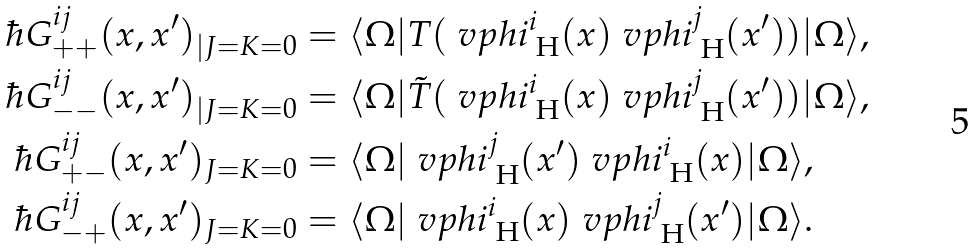Convert formula to latex. <formula><loc_0><loc_0><loc_500><loc_500>\hbar { G } ^ { i j } _ { + + } ( x , x ^ { \prime } ) _ { | J = K = 0 } & = \langle \Omega | T ( \ v p h i _ { \text { H} } ^ { i } ( x ) \ v p h i _ { \text { H} } ^ { j } ( x ^ { \prime } ) ) | \Omega \rangle , \\ \hbar { G } ^ { i j } _ { - - } ( x , x ^ { \prime } ) _ { | J = K = 0 } & = \langle \Omega | \tilde { T } ( \ v p h i _ { \text { H} } ^ { i } ( x ) \ v p h i _ { \text { H} } ^ { j } ( x ^ { \prime } ) ) | \Omega \rangle , \\ \hbar { G } ^ { i j } _ { + - } ( x , x ^ { \prime } ) _ { J = K = 0 } & = \langle \Omega | \ v p h i _ { \text { H} } ^ { j } ( x ^ { \prime } ) \ v p h i _ { \text { H} } ^ { i } ( x ) | \Omega \rangle , \\ \hbar { G } ^ { i j } _ { - + } ( x , x ^ { \prime } ) _ { J = K = 0 } & = \langle \Omega | \ v p h i _ { \text { H} } ^ { i } ( x ) \ v p h i _ { \text { H} } ^ { j } ( x ^ { \prime } ) | \Omega \rangle .</formula> 